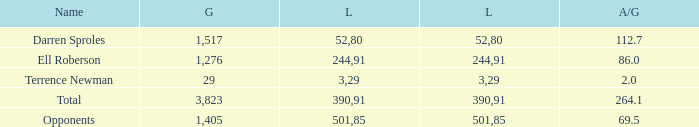What's the sum of all average yards gained when the gained yards is under 1,276 and lost more than 3 yards? None. Can you give me this table as a dict? {'header': ['Name', 'G', 'L', 'L', 'A/G'], 'rows': [['Darren Sproles', '1,517', '52', '80', '112.7'], ['Ell Roberson', '1,276', '244', '91', '86.0'], ['Terrence Newman', '29', '3', '29', '2.0'], ['Total', '3,823', '390', '91', '264.1'], ['Opponents', '1,405', '501', '85', '69.5']]} 